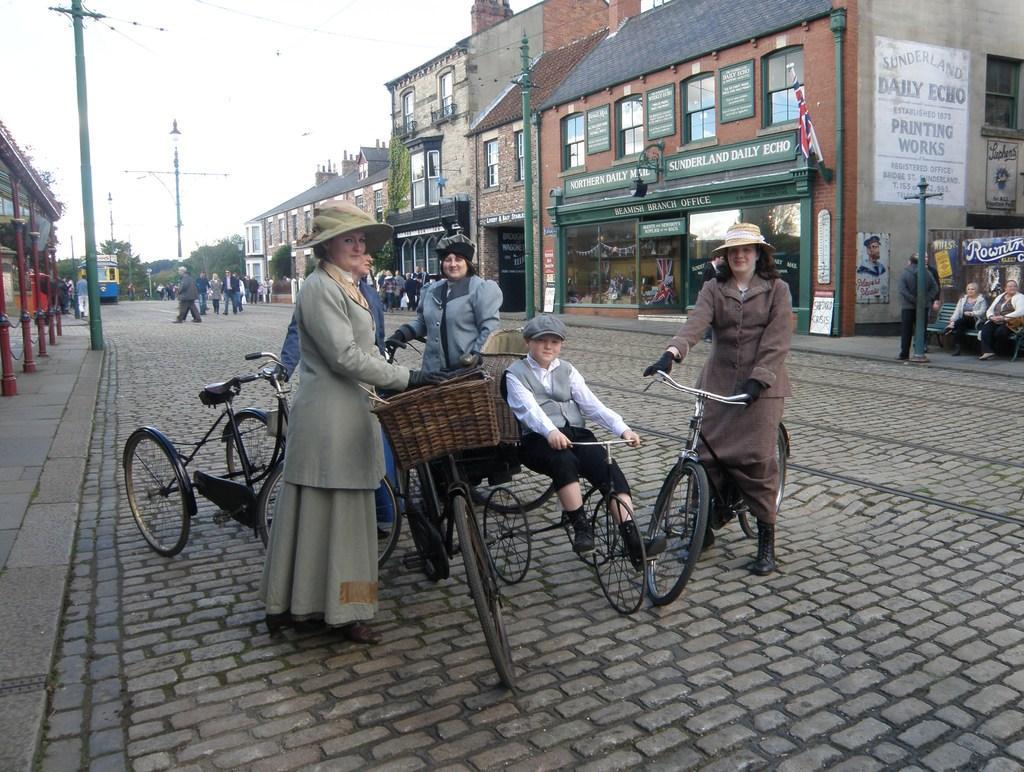In one or two sentences, can you explain what this image depicts? In this picture we can see some people with their bicycles on the road. Here two people are sitting on the bench, one person is leaning on to the pole. And there is a poster on the wall. Here we can see a flag. This is the building. And here we can see some group of people crossing the road. And this is the vehicle. And on the background we can see some trees. And this is the sky. 